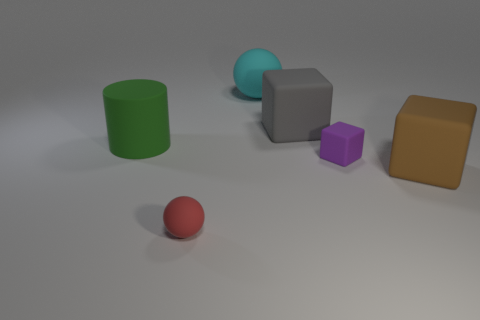The ball that is behind the brown rubber block on the right side of the small thing left of the cyan matte object is what color?
Provide a short and direct response. Cyan. Is the block behind the purple matte object made of the same material as the red ball?
Give a very brief answer. Yes. How many other objects are the same material as the large gray object?
Offer a very short reply. 5. There is a brown object that is the same size as the green thing; what is it made of?
Provide a short and direct response. Rubber. Does the tiny matte thing that is on the left side of the gray matte cube have the same shape as the big thing that is left of the large cyan rubber object?
Provide a succinct answer. No. There is a object that is the same size as the red ball; what shape is it?
Your answer should be compact. Cube. Does the big object that is in front of the green cylinder have the same material as the red object that is in front of the big cyan sphere?
Offer a terse response. Yes. There is a big object to the right of the purple matte block; is there a red ball right of it?
Your answer should be compact. No. What color is the small thing that is made of the same material as the purple block?
Provide a short and direct response. Red. Are there more tiny purple matte things than large yellow matte cubes?
Give a very brief answer. Yes. 